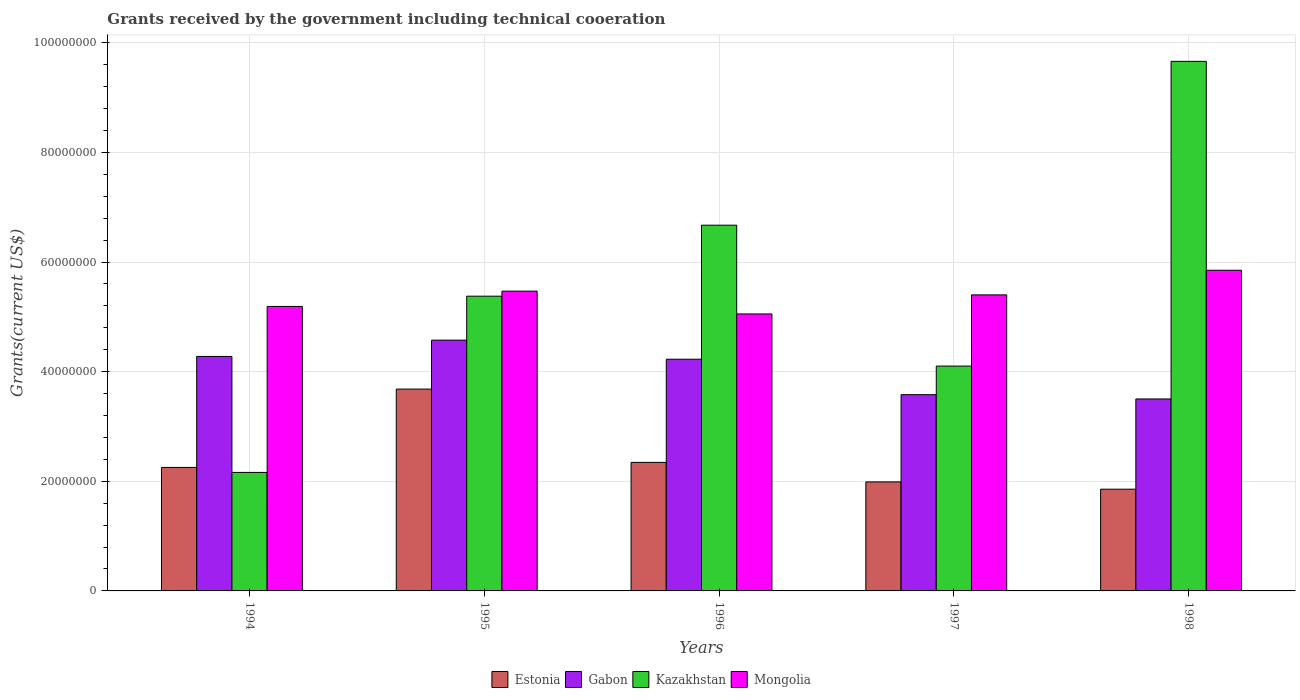How many groups of bars are there?
Provide a short and direct response. 5. How many bars are there on the 3rd tick from the left?
Provide a succinct answer. 4. What is the label of the 4th group of bars from the left?
Ensure brevity in your answer.  1997. In how many cases, is the number of bars for a given year not equal to the number of legend labels?
Your answer should be very brief. 0. What is the total grants received by the government in Estonia in 1995?
Your answer should be very brief. 3.68e+07. Across all years, what is the maximum total grants received by the government in Gabon?
Give a very brief answer. 4.58e+07. Across all years, what is the minimum total grants received by the government in Gabon?
Offer a very short reply. 3.50e+07. In which year was the total grants received by the government in Estonia maximum?
Provide a succinct answer. 1995. What is the total total grants received by the government in Gabon in the graph?
Provide a succinct answer. 2.02e+08. What is the difference between the total grants received by the government in Estonia in 1995 and that in 1997?
Provide a short and direct response. 1.69e+07. What is the difference between the total grants received by the government in Estonia in 1997 and the total grants received by the government in Kazakhstan in 1998?
Provide a short and direct response. -7.67e+07. What is the average total grants received by the government in Kazakhstan per year?
Your answer should be very brief. 5.59e+07. In the year 1998, what is the difference between the total grants received by the government in Estonia and total grants received by the government in Gabon?
Your answer should be very brief. -1.65e+07. In how many years, is the total grants received by the government in Estonia greater than 52000000 US$?
Ensure brevity in your answer.  0. What is the ratio of the total grants received by the government in Estonia in 1994 to that in 1997?
Provide a short and direct response. 1.13. What is the difference between the highest and the second highest total grants received by the government in Mongolia?
Keep it short and to the point. 3.81e+06. What is the difference between the highest and the lowest total grants received by the government in Mongolia?
Offer a very short reply. 7.97e+06. Is it the case that in every year, the sum of the total grants received by the government in Estonia and total grants received by the government in Kazakhstan is greater than the sum of total grants received by the government in Mongolia and total grants received by the government in Gabon?
Keep it short and to the point. No. What does the 1st bar from the left in 1994 represents?
Your answer should be compact. Estonia. What does the 4th bar from the right in 1997 represents?
Your answer should be compact. Estonia. Is it the case that in every year, the sum of the total grants received by the government in Estonia and total grants received by the government in Kazakhstan is greater than the total grants received by the government in Gabon?
Make the answer very short. Yes. How many bars are there?
Make the answer very short. 20. Are all the bars in the graph horizontal?
Your answer should be very brief. No. How many years are there in the graph?
Offer a terse response. 5. What is the difference between two consecutive major ticks on the Y-axis?
Your answer should be compact. 2.00e+07. How many legend labels are there?
Your answer should be very brief. 4. How are the legend labels stacked?
Offer a terse response. Horizontal. What is the title of the graph?
Your response must be concise. Grants received by the government including technical cooeration. Does "Austria" appear as one of the legend labels in the graph?
Your answer should be very brief. No. What is the label or title of the Y-axis?
Provide a succinct answer. Grants(current US$). What is the Grants(current US$) in Estonia in 1994?
Your answer should be very brief. 2.25e+07. What is the Grants(current US$) of Gabon in 1994?
Offer a very short reply. 4.28e+07. What is the Grants(current US$) in Kazakhstan in 1994?
Make the answer very short. 2.16e+07. What is the Grants(current US$) of Mongolia in 1994?
Keep it short and to the point. 5.19e+07. What is the Grants(current US$) of Estonia in 1995?
Keep it short and to the point. 3.68e+07. What is the Grants(current US$) of Gabon in 1995?
Provide a succinct answer. 4.58e+07. What is the Grants(current US$) of Kazakhstan in 1995?
Provide a succinct answer. 5.38e+07. What is the Grants(current US$) of Mongolia in 1995?
Ensure brevity in your answer.  5.47e+07. What is the Grants(current US$) of Estonia in 1996?
Offer a terse response. 2.34e+07. What is the Grants(current US$) of Gabon in 1996?
Your answer should be compact. 4.23e+07. What is the Grants(current US$) in Kazakhstan in 1996?
Provide a short and direct response. 6.67e+07. What is the Grants(current US$) of Mongolia in 1996?
Provide a succinct answer. 5.05e+07. What is the Grants(current US$) in Estonia in 1997?
Your response must be concise. 1.99e+07. What is the Grants(current US$) of Gabon in 1997?
Your response must be concise. 3.58e+07. What is the Grants(current US$) in Kazakhstan in 1997?
Your answer should be compact. 4.10e+07. What is the Grants(current US$) in Mongolia in 1997?
Provide a succinct answer. 5.40e+07. What is the Grants(current US$) in Estonia in 1998?
Provide a short and direct response. 1.86e+07. What is the Grants(current US$) in Gabon in 1998?
Offer a terse response. 3.50e+07. What is the Grants(current US$) in Kazakhstan in 1998?
Provide a short and direct response. 9.66e+07. What is the Grants(current US$) in Mongolia in 1998?
Keep it short and to the point. 5.85e+07. Across all years, what is the maximum Grants(current US$) in Estonia?
Your response must be concise. 3.68e+07. Across all years, what is the maximum Grants(current US$) of Gabon?
Your response must be concise. 4.58e+07. Across all years, what is the maximum Grants(current US$) in Kazakhstan?
Ensure brevity in your answer.  9.66e+07. Across all years, what is the maximum Grants(current US$) in Mongolia?
Your response must be concise. 5.85e+07. Across all years, what is the minimum Grants(current US$) in Estonia?
Ensure brevity in your answer.  1.86e+07. Across all years, what is the minimum Grants(current US$) in Gabon?
Your answer should be compact. 3.50e+07. Across all years, what is the minimum Grants(current US$) of Kazakhstan?
Offer a terse response. 2.16e+07. Across all years, what is the minimum Grants(current US$) of Mongolia?
Your answer should be compact. 5.05e+07. What is the total Grants(current US$) of Estonia in the graph?
Ensure brevity in your answer.  1.21e+08. What is the total Grants(current US$) of Gabon in the graph?
Your answer should be compact. 2.02e+08. What is the total Grants(current US$) of Kazakhstan in the graph?
Your answer should be very brief. 2.80e+08. What is the total Grants(current US$) in Mongolia in the graph?
Make the answer very short. 2.70e+08. What is the difference between the Grants(current US$) of Estonia in 1994 and that in 1995?
Your answer should be very brief. -1.43e+07. What is the difference between the Grants(current US$) of Gabon in 1994 and that in 1995?
Provide a short and direct response. -2.97e+06. What is the difference between the Grants(current US$) of Kazakhstan in 1994 and that in 1995?
Offer a terse response. -3.22e+07. What is the difference between the Grants(current US$) of Mongolia in 1994 and that in 1995?
Make the answer very short. -2.79e+06. What is the difference between the Grants(current US$) of Estonia in 1994 and that in 1996?
Give a very brief answer. -9.20e+05. What is the difference between the Grants(current US$) in Gabon in 1994 and that in 1996?
Keep it short and to the point. 5.10e+05. What is the difference between the Grants(current US$) of Kazakhstan in 1994 and that in 1996?
Provide a succinct answer. -4.51e+07. What is the difference between the Grants(current US$) in Mongolia in 1994 and that in 1996?
Your answer should be very brief. 1.37e+06. What is the difference between the Grants(current US$) in Estonia in 1994 and that in 1997?
Keep it short and to the point. 2.64e+06. What is the difference between the Grants(current US$) in Gabon in 1994 and that in 1997?
Your answer should be compact. 6.98e+06. What is the difference between the Grants(current US$) of Kazakhstan in 1994 and that in 1997?
Give a very brief answer. -1.94e+07. What is the difference between the Grants(current US$) of Mongolia in 1994 and that in 1997?
Your response must be concise. -2.11e+06. What is the difference between the Grants(current US$) in Estonia in 1994 and that in 1998?
Your answer should be very brief. 3.97e+06. What is the difference between the Grants(current US$) in Gabon in 1994 and that in 1998?
Ensure brevity in your answer.  7.76e+06. What is the difference between the Grants(current US$) of Kazakhstan in 1994 and that in 1998?
Make the answer very short. -7.50e+07. What is the difference between the Grants(current US$) in Mongolia in 1994 and that in 1998?
Offer a terse response. -6.60e+06. What is the difference between the Grants(current US$) of Estonia in 1995 and that in 1996?
Your response must be concise. 1.34e+07. What is the difference between the Grants(current US$) in Gabon in 1995 and that in 1996?
Offer a terse response. 3.48e+06. What is the difference between the Grants(current US$) of Kazakhstan in 1995 and that in 1996?
Offer a very short reply. -1.30e+07. What is the difference between the Grants(current US$) in Mongolia in 1995 and that in 1996?
Keep it short and to the point. 4.16e+06. What is the difference between the Grants(current US$) of Estonia in 1995 and that in 1997?
Make the answer very short. 1.69e+07. What is the difference between the Grants(current US$) in Gabon in 1995 and that in 1997?
Your answer should be very brief. 9.95e+06. What is the difference between the Grants(current US$) of Kazakhstan in 1995 and that in 1997?
Give a very brief answer. 1.28e+07. What is the difference between the Grants(current US$) of Mongolia in 1995 and that in 1997?
Offer a terse response. 6.80e+05. What is the difference between the Grants(current US$) of Estonia in 1995 and that in 1998?
Provide a short and direct response. 1.83e+07. What is the difference between the Grants(current US$) in Gabon in 1995 and that in 1998?
Offer a very short reply. 1.07e+07. What is the difference between the Grants(current US$) of Kazakhstan in 1995 and that in 1998?
Provide a short and direct response. -4.28e+07. What is the difference between the Grants(current US$) in Mongolia in 1995 and that in 1998?
Your answer should be very brief. -3.81e+06. What is the difference between the Grants(current US$) in Estonia in 1996 and that in 1997?
Ensure brevity in your answer.  3.56e+06. What is the difference between the Grants(current US$) in Gabon in 1996 and that in 1997?
Make the answer very short. 6.47e+06. What is the difference between the Grants(current US$) of Kazakhstan in 1996 and that in 1997?
Offer a very short reply. 2.57e+07. What is the difference between the Grants(current US$) in Mongolia in 1996 and that in 1997?
Give a very brief answer. -3.48e+06. What is the difference between the Grants(current US$) of Estonia in 1996 and that in 1998?
Keep it short and to the point. 4.89e+06. What is the difference between the Grants(current US$) of Gabon in 1996 and that in 1998?
Provide a succinct answer. 7.25e+06. What is the difference between the Grants(current US$) of Kazakhstan in 1996 and that in 1998?
Offer a very short reply. -2.99e+07. What is the difference between the Grants(current US$) of Mongolia in 1996 and that in 1998?
Ensure brevity in your answer.  -7.97e+06. What is the difference between the Grants(current US$) of Estonia in 1997 and that in 1998?
Keep it short and to the point. 1.33e+06. What is the difference between the Grants(current US$) in Gabon in 1997 and that in 1998?
Your response must be concise. 7.80e+05. What is the difference between the Grants(current US$) in Kazakhstan in 1997 and that in 1998?
Your response must be concise. -5.56e+07. What is the difference between the Grants(current US$) of Mongolia in 1997 and that in 1998?
Offer a very short reply. -4.49e+06. What is the difference between the Grants(current US$) in Estonia in 1994 and the Grants(current US$) in Gabon in 1995?
Ensure brevity in your answer.  -2.32e+07. What is the difference between the Grants(current US$) of Estonia in 1994 and the Grants(current US$) of Kazakhstan in 1995?
Offer a very short reply. -3.12e+07. What is the difference between the Grants(current US$) in Estonia in 1994 and the Grants(current US$) in Mongolia in 1995?
Make the answer very short. -3.22e+07. What is the difference between the Grants(current US$) in Gabon in 1994 and the Grants(current US$) in Kazakhstan in 1995?
Provide a short and direct response. -1.10e+07. What is the difference between the Grants(current US$) in Gabon in 1994 and the Grants(current US$) in Mongolia in 1995?
Offer a terse response. -1.19e+07. What is the difference between the Grants(current US$) of Kazakhstan in 1994 and the Grants(current US$) of Mongolia in 1995?
Provide a succinct answer. -3.31e+07. What is the difference between the Grants(current US$) of Estonia in 1994 and the Grants(current US$) of Gabon in 1996?
Ensure brevity in your answer.  -1.97e+07. What is the difference between the Grants(current US$) in Estonia in 1994 and the Grants(current US$) in Kazakhstan in 1996?
Your answer should be very brief. -4.42e+07. What is the difference between the Grants(current US$) of Estonia in 1994 and the Grants(current US$) of Mongolia in 1996?
Keep it short and to the point. -2.80e+07. What is the difference between the Grants(current US$) in Gabon in 1994 and the Grants(current US$) in Kazakhstan in 1996?
Provide a short and direct response. -2.39e+07. What is the difference between the Grants(current US$) of Gabon in 1994 and the Grants(current US$) of Mongolia in 1996?
Ensure brevity in your answer.  -7.75e+06. What is the difference between the Grants(current US$) in Kazakhstan in 1994 and the Grants(current US$) in Mongolia in 1996?
Offer a terse response. -2.89e+07. What is the difference between the Grants(current US$) of Estonia in 1994 and the Grants(current US$) of Gabon in 1997?
Offer a very short reply. -1.33e+07. What is the difference between the Grants(current US$) in Estonia in 1994 and the Grants(current US$) in Kazakhstan in 1997?
Ensure brevity in your answer.  -1.85e+07. What is the difference between the Grants(current US$) in Estonia in 1994 and the Grants(current US$) in Mongolia in 1997?
Your response must be concise. -3.15e+07. What is the difference between the Grants(current US$) of Gabon in 1994 and the Grants(current US$) of Kazakhstan in 1997?
Your answer should be compact. 1.76e+06. What is the difference between the Grants(current US$) in Gabon in 1994 and the Grants(current US$) in Mongolia in 1997?
Your response must be concise. -1.12e+07. What is the difference between the Grants(current US$) in Kazakhstan in 1994 and the Grants(current US$) in Mongolia in 1997?
Ensure brevity in your answer.  -3.24e+07. What is the difference between the Grants(current US$) of Estonia in 1994 and the Grants(current US$) of Gabon in 1998?
Provide a succinct answer. -1.25e+07. What is the difference between the Grants(current US$) in Estonia in 1994 and the Grants(current US$) in Kazakhstan in 1998?
Ensure brevity in your answer.  -7.41e+07. What is the difference between the Grants(current US$) in Estonia in 1994 and the Grants(current US$) in Mongolia in 1998?
Make the answer very short. -3.60e+07. What is the difference between the Grants(current US$) in Gabon in 1994 and the Grants(current US$) in Kazakhstan in 1998?
Offer a very short reply. -5.38e+07. What is the difference between the Grants(current US$) in Gabon in 1994 and the Grants(current US$) in Mongolia in 1998?
Your response must be concise. -1.57e+07. What is the difference between the Grants(current US$) of Kazakhstan in 1994 and the Grants(current US$) of Mongolia in 1998?
Your answer should be compact. -3.69e+07. What is the difference between the Grants(current US$) of Estonia in 1995 and the Grants(current US$) of Gabon in 1996?
Offer a very short reply. -5.45e+06. What is the difference between the Grants(current US$) of Estonia in 1995 and the Grants(current US$) of Kazakhstan in 1996?
Your answer should be compact. -2.99e+07. What is the difference between the Grants(current US$) in Estonia in 1995 and the Grants(current US$) in Mongolia in 1996?
Provide a succinct answer. -1.37e+07. What is the difference between the Grants(current US$) of Gabon in 1995 and the Grants(current US$) of Kazakhstan in 1996?
Make the answer very short. -2.10e+07. What is the difference between the Grants(current US$) of Gabon in 1995 and the Grants(current US$) of Mongolia in 1996?
Your response must be concise. -4.78e+06. What is the difference between the Grants(current US$) of Kazakhstan in 1995 and the Grants(current US$) of Mongolia in 1996?
Give a very brief answer. 3.24e+06. What is the difference between the Grants(current US$) in Estonia in 1995 and the Grants(current US$) in Gabon in 1997?
Your answer should be very brief. 1.02e+06. What is the difference between the Grants(current US$) of Estonia in 1995 and the Grants(current US$) of Kazakhstan in 1997?
Offer a terse response. -4.20e+06. What is the difference between the Grants(current US$) in Estonia in 1995 and the Grants(current US$) in Mongolia in 1997?
Offer a terse response. -1.72e+07. What is the difference between the Grants(current US$) of Gabon in 1995 and the Grants(current US$) of Kazakhstan in 1997?
Provide a short and direct response. 4.73e+06. What is the difference between the Grants(current US$) of Gabon in 1995 and the Grants(current US$) of Mongolia in 1997?
Your answer should be compact. -8.26e+06. What is the difference between the Grants(current US$) of Estonia in 1995 and the Grants(current US$) of Gabon in 1998?
Ensure brevity in your answer.  1.80e+06. What is the difference between the Grants(current US$) in Estonia in 1995 and the Grants(current US$) in Kazakhstan in 1998?
Provide a short and direct response. -5.98e+07. What is the difference between the Grants(current US$) in Estonia in 1995 and the Grants(current US$) in Mongolia in 1998?
Your answer should be very brief. -2.17e+07. What is the difference between the Grants(current US$) of Gabon in 1995 and the Grants(current US$) of Kazakhstan in 1998?
Offer a very short reply. -5.09e+07. What is the difference between the Grants(current US$) of Gabon in 1995 and the Grants(current US$) of Mongolia in 1998?
Provide a short and direct response. -1.28e+07. What is the difference between the Grants(current US$) of Kazakhstan in 1995 and the Grants(current US$) of Mongolia in 1998?
Keep it short and to the point. -4.73e+06. What is the difference between the Grants(current US$) of Estonia in 1996 and the Grants(current US$) of Gabon in 1997?
Make the answer very short. -1.24e+07. What is the difference between the Grants(current US$) of Estonia in 1996 and the Grants(current US$) of Kazakhstan in 1997?
Offer a terse response. -1.76e+07. What is the difference between the Grants(current US$) of Estonia in 1996 and the Grants(current US$) of Mongolia in 1997?
Offer a very short reply. -3.06e+07. What is the difference between the Grants(current US$) of Gabon in 1996 and the Grants(current US$) of Kazakhstan in 1997?
Provide a short and direct response. 1.25e+06. What is the difference between the Grants(current US$) of Gabon in 1996 and the Grants(current US$) of Mongolia in 1997?
Make the answer very short. -1.17e+07. What is the difference between the Grants(current US$) in Kazakhstan in 1996 and the Grants(current US$) in Mongolia in 1997?
Your answer should be compact. 1.27e+07. What is the difference between the Grants(current US$) of Estonia in 1996 and the Grants(current US$) of Gabon in 1998?
Your answer should be very brief. -1.16e+07. What is the difference between the Grants(current US$) in Estonia in 1996 and the Grants(current US$) in Kazakhstan in 1998?
Offer a terse response. -7.32e+07. What is the difference between the Grants(current US$) in Estonia in 1996 and the Grants(current US$) in Mongolia in 1998?
Your answer should be very brief. -3.50e+07. What is the difference between the Grants(current US$) of Gabon in 1996 and the Grants(current US$) of Kazakhstan in 1998?
Your answer should be compact. -5.43e+07. What is the difference between the Grants(current US$) of Gabon in 1996 and the Grants(current US$) of Mongolia in 1998?
Make the answer very short. -1.62e+07. What is the difference between the Grants(current US$) in Kazakhstan in 1996 and the Grants(current US$) in Mongolia in 1998?
Offer a very short reply. 8.22e+06. What is the difference between the Grants(current US$) in Estonia in 1997 and the Grants(current US$) in Gabon in 1998?
Offer a terse response. -1.51e+07. What is the difference between the Grants(current US$) in Estonia in 1997 and the Grants(current US$) in Kazakhstan in 1998?
Offer a terse response. -7.67e+07. What is the difference between the Grants(current US$) in Estonia in 1997 and the Grants(current US$) in Mongolia in 1998?
Keep it short and to the point. -3.86e+07. What is the difference between the Grants(current US$) in Gabon in 1997 and the Grants(current US$) in Kazakhstan in 1998?
Offer a very short reply. -6.08e+07. What is the difference between the Grants(current US$) of Gabon in 1997 and the Grants(current US$) of Mongolia in 1998?
Offer a very short reply. -2.27e+07. What is the difference between the Grants(current US$) in Kazakhstan in 1997 and the Grants(current US$) in Mongolia in 1998?
Provide a succinct answer. -1.75e+07. What is the average Grants(current US$) in Estonia per year?
Your answer should be very brief. 2.42e+07. What is the average Grants(current US$) in Gabon per year?
Your answer should be very brief. 4.03e+07. What is the average Grants(current US$) of Kazakhstan per year?
Your answer should be very brief. 5.59e+07. What is the average Grants(current US$) in Mongolia per year?
Your response must be concise. 5.39e+07. In the year 1994, what is the difference between the Grants(current US$) of Estonia and Grants(current US$) of Gabon?
Your response must be concise. -2.02e+07. In the year 1994, what is the difference between the Grants(current US$) of Estonia and Grants(current US$) of Kazakhstan?
Keep it short and to the point. 9.10e+05. In the year 1994, what is the difference between the Grants(current US$) of Estonia and Grants(current US$) of Mongolia?
Offer a very short reply. -2.94e+07. In the year 1994, what is the difference between the Grants(current US$) of Gabon and Grants(current US$) of Kazakhstan?
Offer a terse response. 2.12e+07. In the year 1994, what is the difference between the Grants(current US$) of Gabon and Grants(current US$) of Mongolia?
Your answer should be compact. -9.12e+06. In the year 1994, what is the difference between the Grants(current US$) in Kazakhstan and Grants(current US$) in Mongolia?
Give a very brief answer. -3.03e+07. In the year 1995, what is the difference between the Grants(current US$) in Estonia and Grants(current US$) in Gabon?
Keep it short and to the point. -8.93e+06. In the year 1995, what is the difference between the Grants(current US$) of Estonia and Grants(current US$) of Kazakhstan?
Make the answer very short. -1.70e+07. In the year 1995, what is the difference between the Grants(current US$) of Estonia and Grants(current US$) of Mongolia?
Offer a terse response. -1.79e+07. In the year 1995, what is the difference between the Grants(current US$) of Gabon and Grants(current US$) of Kazakhstan?
Provide a short and direct response. -8.02e+06. In the year 1995, what is the difference between the Grants(current US$) in Gabon and Grants(current US$) in Mongolia?
Give a very brief answer. -8.94e+06. In the year 1995, what is the difference between the Grants(current US$) of Kazakhstan and Grants(current US$) of Mongolia?
Keep it short and to the point. -9.20e+05. In the year 1996, what is the difference between the Grants(current US$) in Estonia and Grants(current US$) in Gabon?
Offer a terse response. -1.88e+07. In the year 1996, what is the difference between the Grants(current US$) of Estonia and Grants(current US$) of Kazakhstan?
Keep it short and to the point. -4.33e+07. In the year 1996, what is the difference between the Grants(current US$) of Estonia and Grants(current US$) of Mongolia?
Keep it short and to the point. -2.71e+07. In the year 1996, what is the difference between the Grants(current US$) in Gabon and Grants(current US$) in Kazakhstan?
Offer a very short reply. -2.44e+07. In the year 1996, what is the difference between the Grants(current US$) of Gabon and Grants(current US$) of Mongolia?
Your response must be concise. -8.26e+06. In the year 1996, what is the difference between the Grants(current US$) in Kazakhstan and Grants(current US$) in Mongolia?
Your answer should be compact. 1.62e+07. In the year 1997, what is the difference between the Grants(current US$) in Estonia and Grants(current US$) in Gabon?
Provide a short and direct response. -1.59e+07. In the year 1997, what is the difference between the Grants(current US$) in Estonia and Grants(current US$) in Kazakhstan?
Offer a very short reply. -2.11e+07. In the year 1997, what is the difference between the Grants(current US$) of Estonia and Grants(current US$) of Mongolia?
Provide a short and direct response. -3.41e+07. In the year 1997, what is the difference between the Grants(current US$) in Gabon and Grants(current US$) in Kazakhstan?
Give a very brief answer. -5.22e+06. In the year 1997, what is the difference between the Grants(current US$) in Gabon and Grants(current US$) in Mongolia?
Give a very brief answer. -1.82e+07. In the year 1997, what is the difference between the Grants(current US$) of Kazakhstan and Grants(current US$) of Mongolia?
Provide a succinct answer. -1.30e+07. In the year 1998, what is the difference between the Grants(current US$) in Estonia and Grants(current US$) in Gabon?
Your answer should be very brief. -1.65e+07. In the year 1998, what is the difference between the Grants(current US$) of Estonia and Grants(current US$) of Kazakhstan?
Your answer should be very brief. -7.80e+07. In the year 1998, what is the difference between the Grants(current US$) of Estonia and Grants(current US$) of Mongolia?
Give a very brief answer. -3.99e+07. In the year 1998, what is the difference between the Grants(current US$) of Gabon and Grants(current US$) of Kazakhstan?
Ensure brevity in your answer.  -6.16e+07. In the year 1998, what is the difference between the Grants(current US$) of Gabon and Grants(current US$) of Mongolia?
Give a very brief answer. -2.35e+07. In the year 1998, what is the difference between the Grants(current US$) of Kazakhstan and Grants(current US$) of Mongolia?
Make the answer very short. 3.81e+07. What is the ratio of the Grants(current US$) in Estonia in 1994 to that in 1995?
Your answer should be compact. 0.61. What is the ratio of the Grants(current US$) of Gabon in 1994 to that in 1995?
Ensure brevity in your answer.  0.94. What is the ratio of the Grants(current US$) in Kazakhstan in 1994 to that in 1995?
Provide a short and direct response. 0.4. What is the ratio of the Grants(current US$) of Mongolia in 1994 to that in 1995?
Give a very brief answer. 0.95. What is the ratio of the Grants(current US$) of Estonia in 1994 to that in 1996?
Give a very brief answer. 0.96. What is the ratio of the Grants(current US$) in Gabon in 1994 to that in 1996?
Your answer should be compact. 1.01. What is the ratio of the Grants(current US$) of Kazakhstan in 1994 to that in 1996?
Ensure brevity in your answer.  0.32. What is the ratio of the Grants(current US$) of Mongolia in 1994 to that in 1996?
Give a very brief answer. 1.03. What is the ratio of the Grants(current US$) in Estonia in 1994 to that in 1997?
Offer a terse response. 1.13. What is the ratio of the Grants(current US$) of Gabon in 1994 to that in 1997?
Offer a very short reply. 1.2. What is the ratio of the Grants(current US$) of Kazakhstan in 1994 to that in 1997?
Your response must be concise. 0.53. What is the ratio of the Grants(current US$) in Mongolia in 1994 to that in 1997?
Make the answer very short. 0.96. What is the ratio of the Grants(current US$) in Estonia in 1994 to that in 1998?
Provide a short and direct response. 1.21. What is the ratio of the Grants(current US$) in Gabon in 1994 to that in 1998?
Keep it short and to the point. 1.22. What is the ratio of the Grants(current US$) in Kazakhstan in 1994 to that in 1998?
Provide a short and direct response. 0.22. What is the ratio of the Grants(current US$) in Mongolia in 1994 to that in 1998?
Ensure brevity in your answer.  0.89. What is the ratio of the Grants(current US$) of Estonia in 1995 to that in 1996?
Offer a terse response. 1.57. What is the ratio of the Grants(current US$) of Gabon in 1995 to that in 1996?
Make the answer very short. 1.08. What is the ratio of the Grants(current US$) in Kazakhstan in 1995 to that in 1996?
Your response must be concise. 0.81. What is the ratio of the Grants(current US$) of Mongolia in 1995 to that in 1996?
Your answer should be compact. 1.08. What is the ratio of the Grants(current US$) in Estonia in 1995 to that in 1997?
Provide a short and direct response. 1.85. What is the ratio of the Grants(current US$) of Gabon in 1995 to that in 1997?
Offer a terse response. 1.28. What is the ratio of the Grants(current US$) in Kazakhstan in 1995 to that in 1997?
Make the answer very short. 1.31. What is the ratio of the Grants(current US$) in Mongolia in 1995 to that in 1997?
Your response must be concise. 1.01. What is the ratio of the Grants(current US$) in Estonia in 1995 to that in 1998?
Ensure brevity in your answer.  1.98. What is the ratio of the Grants(current US$) of Gabon in 1995 to that in 1998?
Give a very brief answer. 1.31. What is the ratio of the Grants(current US$) in Kazakhstan in 1995 to that in 1998?
Offer a terse response. 0.56. What is the ratio of the Grants(current US$) of Mongolia in 1995 to that in 1998?
Offer a very short reply. 0.93. What is the ratio of the Grants(current US$) of Estonia in 1996 to that in 1997?
Keep it short and to the point. 1.18. What is the ratio of the Grants(current US$) of Gabon in 1996 to that in 1997?
Keep it short and to the point. 1.18. What is the ratio of the Grants(current US$) of Kazakhstan in 1996 to that in 1997?
Your answer should be very brief. 1.63. What is the ratio of the Grants(current US$) of Mongolia in 1996 to that in 1997?
Ensure brevity in your answer.  0.94. What is the ratio of the Grants(current US$) in Estonia in 1996 to that in 1998?
Offer a very short reply. 1.26. What is the ratio of the Grants(current US$) in Gabon in 1996 to that in 1998?
Keep it short and to the point. 1.21. What is the ratio of the Grants(current US$) in Kazakhstan in 1996 to that in 1998?
Offer a very short reply. 0.69. What is the ratio of the Grants(current US$) of Mongolia in 1996 to that in 1998?
Keep it short and to the point. 0.86. What is the ratio of the Grants(current US$) in Estonia in 1997 to that in 1998?
Keep it short and to the point. 1.07. What is the ratio of the Grants(current US$) in Gabon in 1997 to that in 1998?
Provide a short and direct response. 1.02. What is the ratio of the Grants(current US$) of Kazakhstan in 1997 to that in 1998?
Make the answer very short. 0.42. What is the ratio of the Grants(current US$) in Mongolia in 1997 to that in 1998?
Make the answer very short. 0.92. What is the difference between the highest and the second highest Grants(current US$) of Estonia?
Your response must be concise. 1.34e+07. What is the difference between the highest and the second highest Grants(current US$) of Gabon?
Keep it short and to the point. 2.97e+06. What is the difference between the highest and the second highest Grants(current US$) of Kazakhstan?
Ensure brevity in your answer.  2.99e+07. What is the difference between the highest and the second highest Grants(current US$) of Mongolia?
Give a very brief answer. 3.81e+06. What is the difference between the highest and the lowest Grants(current US$) of Estonia?
Ensure brevity in your answer.  1.83e+07. What is the difference between the highest and the lowest Grants(current US$) of Gabon?
Your response must be concise. 1.07e+07. What is the difference between the highest and the lowest Grants(current US$) in Kazakhstan?
Your response must be concise. 7.50e+07. What is the difference between the highest and the lowest Grants(current US$) of Mongolia?
Make the answer very short. 7.97e+06. 